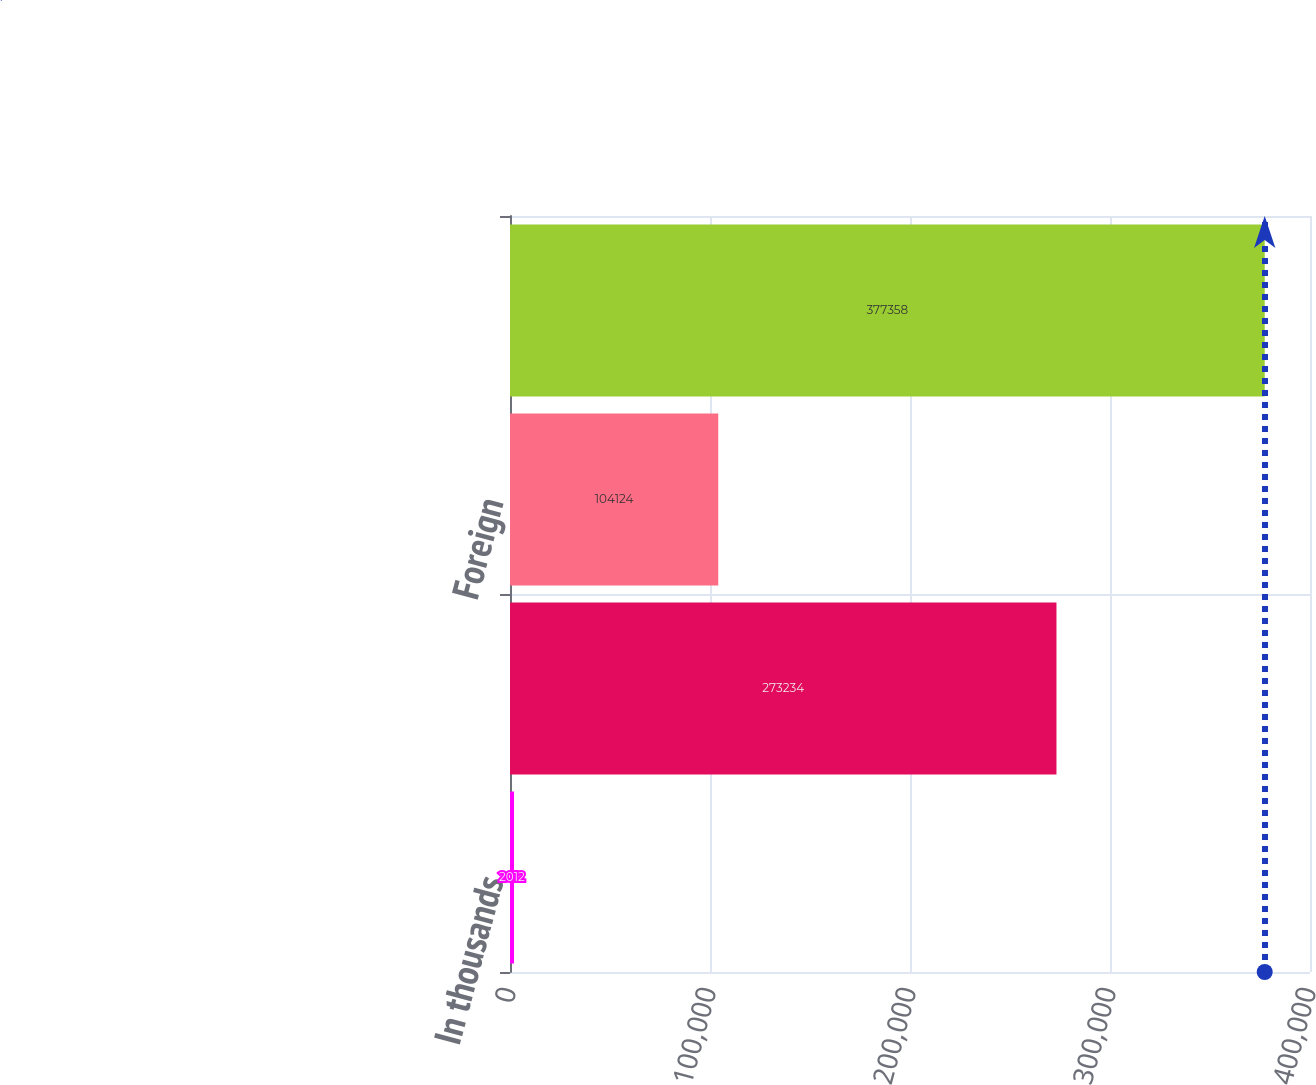Convert chart. <chart><loc_0><loc_0><loc_500><loc_500><bar_chart><fcel>In thousands<fcel>Domestic<fcel>Foreign<fcel>Income from operations before<nl><fcel>2012<fcel>273234<fcel>104124<fcel>377358<nl></chart> 